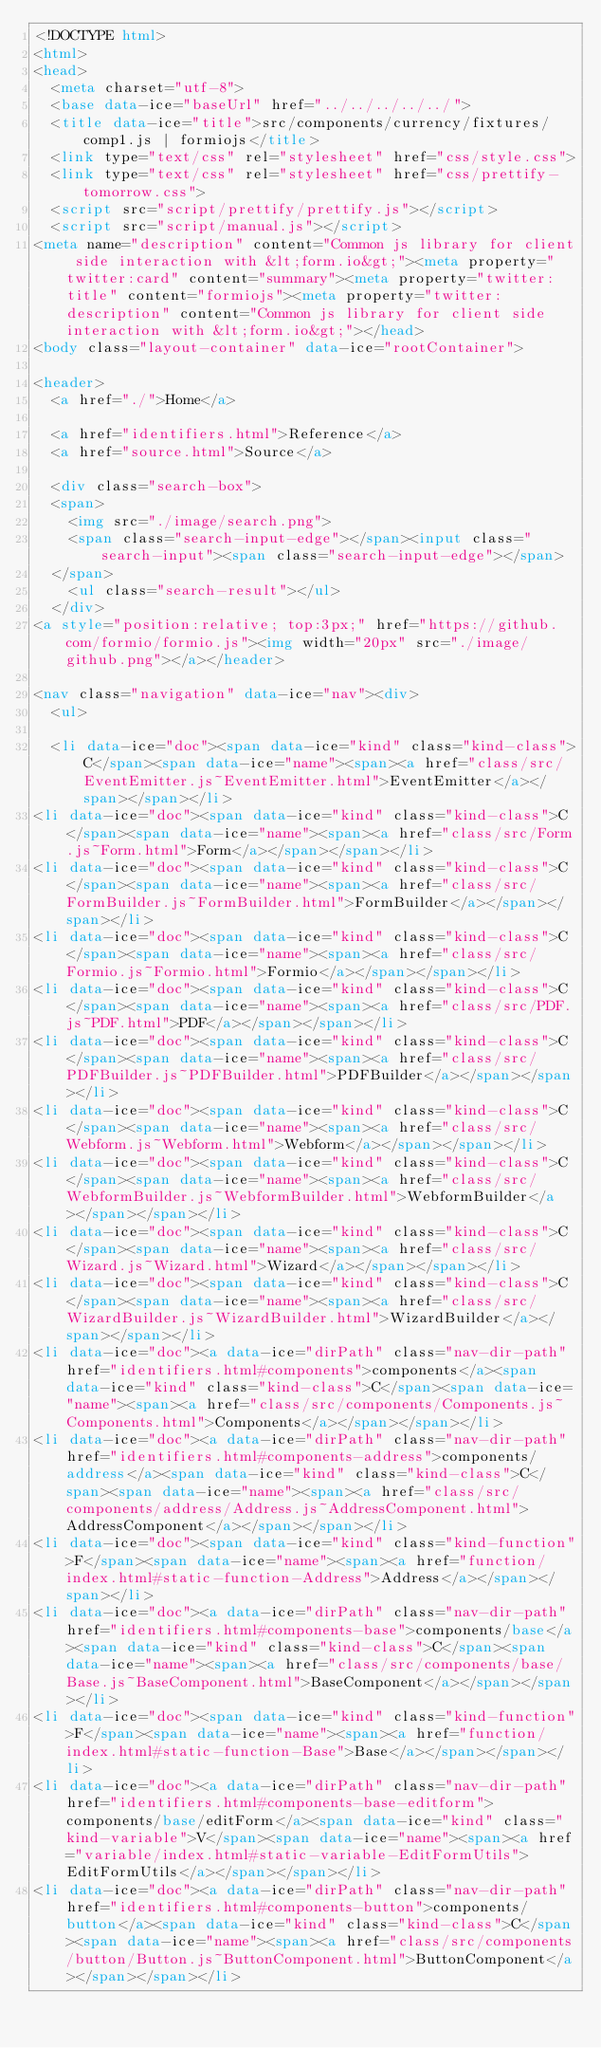<code> <loc_0><loc_0><loc_500><loc_500><_HTML_><!DOCTYPE html>
<html>
<head>
  <meta charset="utf-8">
  <base data-ice="baseUrl" href="../../../../../">
  <title data-ice="title">src/components/currency/fixtures/comp1.js | formiojs</title>
  <link type="text/css" rel="stylesheet" href="css/style.css">
  <link type="text/css" rel="stylesheet" href="css/prettify-tomorrow.css">
  <script src="script/prettify/prettify.js"></script>
  <script src="script/manual.js"></script>
<meta name="description" content="Common js library for client side interaction with &lt;form.io&gt;"><meta property="twitter:card" content="summary"><meta property="twitter:title" content="formiojs"><meta property="twitter:description" content="Common js library for client side interaction with &lt;form.io&gt;"></head>
<body class="layout-container" data-ice="rootContainer">

<header>
  <a href="./">Home</a>
  
  <a href="identifiers.html">Reference</a>
  <a href="source.html">Source</a>
  
  <div class="search-box">
  <span>
    <img src="./image/search.png">
    <span class="search-input-edge"></span><input class="search-input"><span class="search-input-edge"></span>
  </span>
    <ul class="search-result"></ul>
  </div>
<a style="position:relative; top:3px;" href="https://github.com/formio/formio.js"><img width="20px" src="./image/github.png"></a></header>

<nav class="navigation" data-ice="nav"><div>
  <ul>
    
  <li data-ice="doc"><span data-ice="kind" class="kind-class">C</span><span data-ice="name"><span><a href="class/src/EventEmitter.js~EventEmitter.html">EventEmitter</a></span></span></li>
<li data-ice="doc"><span data-ice="kind" class="kind-class">C</span><span data-ice="name"><span><a href="class/src/Form.js~Form.html">Form</a></span></span></li>
<li data-ice="doc"><span data-ice="kind" class="kind-class">C</span><span data-ice="name"><span><a href="class/src/FormBuilder.js~FormBuilder.html">FormBuilder</a></span></span></li>
<li data-ice="doc"><span data-ice="kind" class="kind-class">C</span><span data-ice="name"><span><a href="class/src/Formio.js~Formio.html">Formio</a></span></span></li>
<li data-ice="doc"><span data-ice="kind" class="kind-class">C</span><span data-ice="name"><span><a href="class/src/PDF.js~PDF.html">PDF</a></span></span></li>
<li data-ice="doc"><span data-ice="kind" class="kind-class">C</span><span data-ice="name"><span><a href="class/src/PDFBuilder.js~PDFBuilder.html">PDFBuilder</a></span></span></li>
<li data-ice="doc"><span data-ice="kind" class="kind-class">C</span><span data-ice="name"><span><a href="class/src/Webform.js~Webform.html">Webform</a></span></span></li>
<li data-ice="doc"><span data-ice="kind" class="kind-class">C</span><span data-ice="name"><span><a href="class/src/WebformBuilder.js~WebformBuilder.html">WebformBuilder</a></span></span></li>
<li data-ice="doc"><span data-ice="kind" class="kind-class">C</span><span data-ice="name"><span><a href="class/src/Wizard.js~Wizard.html">Wizard</a></span></span></li>
<li data-ice="doc"><span data-ice="kind" class="kind-class">C</span><span data-ice="name"><span><a href="class/src/WizardBuilder.js~WizardBuilder.html">WizardBuilder</a></span></span></li>
<li data-ice="doc"><a data-ice="dirPath" class="nav-dir-path" href="identifiers.html#components">components</a><span data-ice="kind" class="kind-class">C</span><span data-ice="name"><span><a href="class/src/components/Components.js~Components.html">Components</a></span></span></li>
<li data-ice="doc"><a data-ice="dirPath" class="nav-dir-path" href="identifiers.html#components-address">components/address</a><span data-ice="kind" class="kind-class">C</span><span data-ice="name"><span><a href="class/src/components/address/Address.js~AddressComponent.html">AddressComponent</a></span></span></li>
<li data-ice="doc"><span data-ice="kind" class="kind-function">F</span><span data-ice="name"><span><a href="function/index.html#static-function-Address">Address</a></span></span></li>
<li data-ice="doc"><a data-ice="dirPath" class="nav-dir-path" href="identifiers.html#components-base">components/base</a><span data-ice="kind" class="kind-class">C</span><span data-ice="name"><span><a href="class/src/components/base/Base.js~BaseComponent.html">BaseComponent</a></span></span></li>
<li data-ice="doc"><span data-ice="kind" class="kind-function">F</span><span data-ice="name"><span><a href="function/index.html#static-function-Base">Base</a></span></span></li>
<li data-ice="doc"><a data-ice="dirPath" class="nav-dir-path" href="identifiers.html#components-base-editform">components/base/editForm</a><span data-ice="kind" class="kind-variable">V</span><span data-ice="name"><span><a href="variable/index.html#static-variable-EditFormUtils">EditFormUtils</a></span></span></li>
<li data-ice="doc"><a data-ice="dirPath" class="nav-dir-path" href="identifiers.html#components-button">components/button</a><span data-ice="kind" class="kind-class">C</span><span data-ice="name"><span><a href="class/src/components/button/Button.js~ButtonComponent.html">ButtonComponent</a></span></span></li></code> 